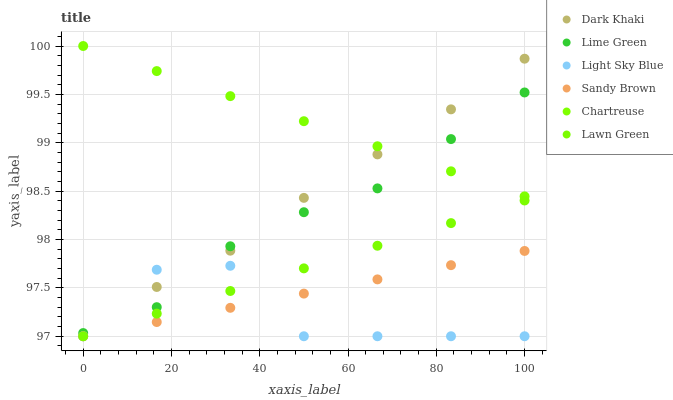Does Light Sky Blue have the minimum area under the curve?
Answer yes or no. Yes. Does Chartreuse have the maximum area under the curve?
Answer yes or no. Yes. Does Lime Green have the minimum area under the curve?
Answer yes or no. No. Does Lime Green have the maximum area under the curve?
Answer yes or no. No. Is Lawn Green the smoothest?
Answer yes or no. Yes. Is Light Sky Blue the roughest?
Answer yes or no. Yes. Is Lime Green the smoothest?
Answer yes or no. No. Is Lime Green the roughest?
Answer yes or no. No. Does Lawn Green have the lowest value?
Answer yes or no. Yes. Does Lime Green have the lowest value?
Answer yes or no. No. Does Chartreuse have the highest value?
Answer yes or no. Yes. Does Lime Green have the highest value?
Answer yes or no. No. Is Sandy Brown less than Lime Green?
Answer yes or no. Yes. Is Lime Green greater than Sandy Brown?
Answer yes or no. Yes. Does Dark Khaki intersect Lime Green?
Answer yes or no. Yes. Is Dark Khaki less than Lime Green?
Answer yes or no. No. Is Dark Khaki greater than Lime Green?
Answer yes or no. No. Does Sandy Brown intersect Lime Green?
Answer yes or no. No. 